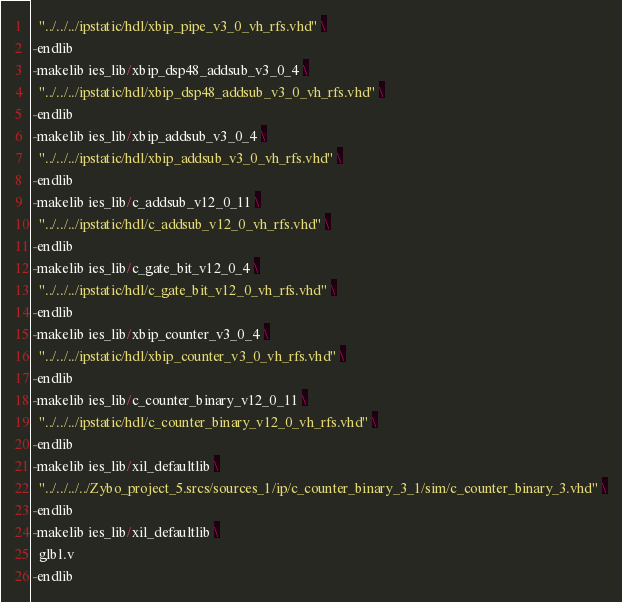<code> <loc_0><loc_0><loc_500><loc_500><_FORTRAN_>  "../../../ipstatic/hdl/xbip_pipe_v3_0_vh_rfs.vhd" \
-endlib
-makelib ies_lib/xbip_dsp48_addsub_v3_0_4 \
  "../../../ipstatic/hdl/xbip_dsp48_addsub_v3_0_vh_rfs.vhd" \
-endlib
-makelib ies_lib/xbip_addsub_v3_0_4 \
  "../../../ipstatic/hdl/xbip_addsub_v3_0_vh_rfs.vhd" \
-endlib
-makelib ies_lib/c_addsub_v12_0_11 \
  "../../../ipstatic/hdl/c_addsub_v12_0_vh_rfs.vhd" \
-endlib
-makelib ies_lib/c_gate_bit_v12_0_4 \
  "../../../ipstatic/hdl/c_gate_bit_v12_0_vh_rfs.vhd" \
-endlib
-makelib ies_lib/xbip_counter_v3_0_4 \
  "../../../ipstatic/hdl/xbip_counter_v3_0_vh_rfs.vhd" \
-endlib
-makelib ies_lib/c_counter_binary_v12_0_11 \
  "../../../ipstatic/hdl/c_counter_binary_v12_0_vh_rfs.vhd" \
-endlib
-makelib ies_lib/xil_defaultlib \
  "../../../../Zybo_project_5.srcs/sources_1/ip/c_counter_binary_3_1/sim/c_counter_binary_3.vhd" \
-endlib
-makelib ies_lib/xil_defaultlib \
  glbl.v
-endlib

</code> 